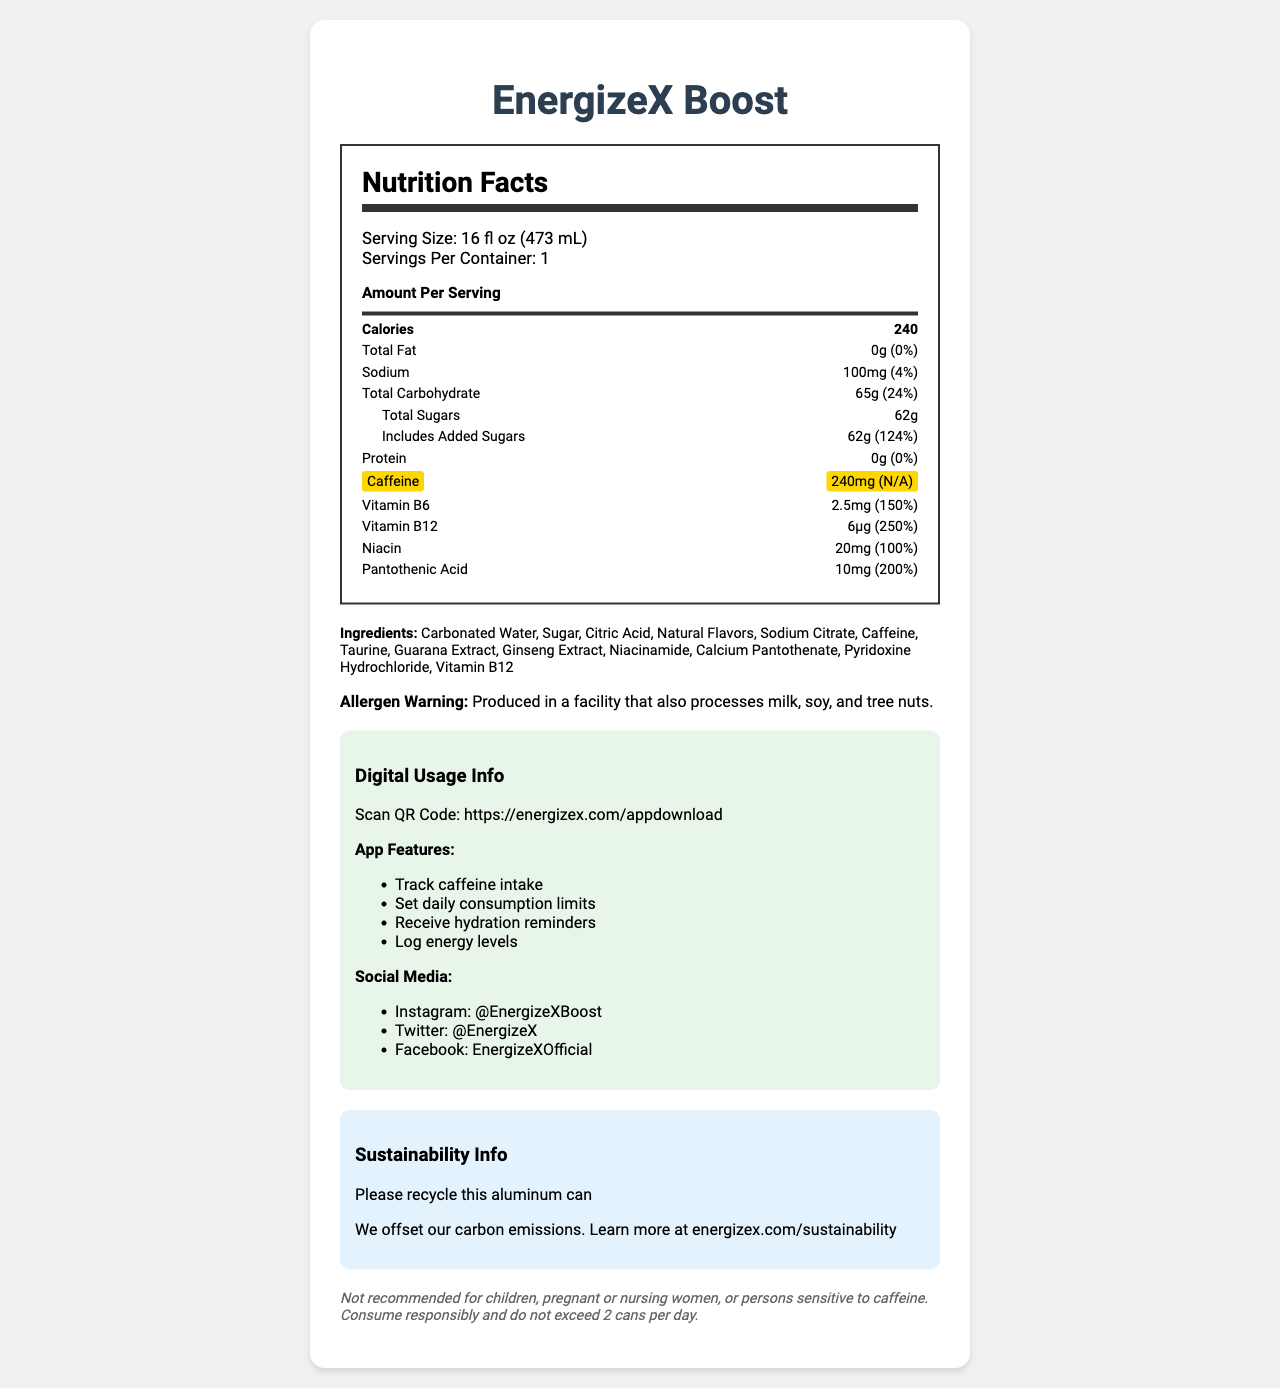what is the serving size? The serving size is clearly stated at the beginning of the nutrition label.
Answer: 16 fl oz (473 mL) how many calories are in one serving of EnergizeX Boost? The calorie count per serving is listed right after the serving size.
Answer: 240 how much caffeine is in one can of this energy drink? The caffeine content is highlighted on the label.
Answer: 240mg what is the percentage of the daily value for sodium in one serving? The percentage daily value for sodium is mentioned next to its amount.
Answer: 4% which vitamins are included in the energy drink, and what are their daily values? The vitamins and their daily values are listed in the nutrient section.
Answer: Vitamin B6 (150%), Vitamin B12 (250%), Niacin (100%), Pantothenic Acid (200%) what is the amount of added sugars in the energy drink? The amount for added sugars is listed under the total sugars section.
Answer: 62g which warning is mentioned about potential allergens? The allergen warning is provided at the bottom of the label.
Answer: Produced in a facility that also processes milk, soy, and tree nuts. can you track your caffeine intake using the associated app? The app features listed include tracking caffeine intake.
Answer: Yes is it safe for children to consume this product? The legal disclaimer states that it is not recommended for children.
Answer: No is this can recyclable? The sustainability info clearly states "Please recycle this aluminum can."
Answer: Yes which of the following is not an ingredient in EnergizeX Boost? A. Carbonated Water B. Orange Juice C. Guarana Extract D. Sugar Orange Juice is not listed among the ingredients.
Answer: B the app associated with EnergizeX Boost allows you to do all of the following except: A. Track caffeine intake B. Set daily consumption limits C. Log your workouts D. Receive hydration reminders Logging your workouts is not listed as an app feature.
Answer: C is there a QR code mentioned for downloading an app? The digital usage info includes a QR code.
Answer: Yes describe the main idea of this document. The document provides comprehensive information on the energy drink's nutrition, ingredients, associated app features for tracking usage, and sustainability initiatives, along with legal disclaimers about consumption.
Answer: The document is a detailed nutrition facts label for the EnergizeX Boost energy drink, including nutritional content, ingredient list, allergen warnings, and additional features related to an associated app, sustainability information, and legal disclaimers. what is the caffeine dosage recommendation according to the legal disclaimer? The legal disclaimer mentions the recommendation not to exceed 2 cans per day.
Answer: Do not exceed 2 cans per day. who should avoid consuming EnergizeX Boost? The legal disclaimer advises against consumption by children, pregnant or nursing women, or individuals sensitive to caffeine.
Answer: Children, pregnant or nursing women, or persons sensitive to caffeine. how many grams of total carbohydrates are present in one serving? The total carbohydrate content is listed next to the percentage daily value for total carbohydrates.
Answer: 65g does the nutrition label mention any information about the product's carbon footprint? The sustainability section indicates that the carbon emissions are offset, with more information available on their website.
Answer: Yes what percentage of the daily value of added sugars does one serving contain? The daily value percentage of added sugars is explicitly mentioned.
Answer: 124% 